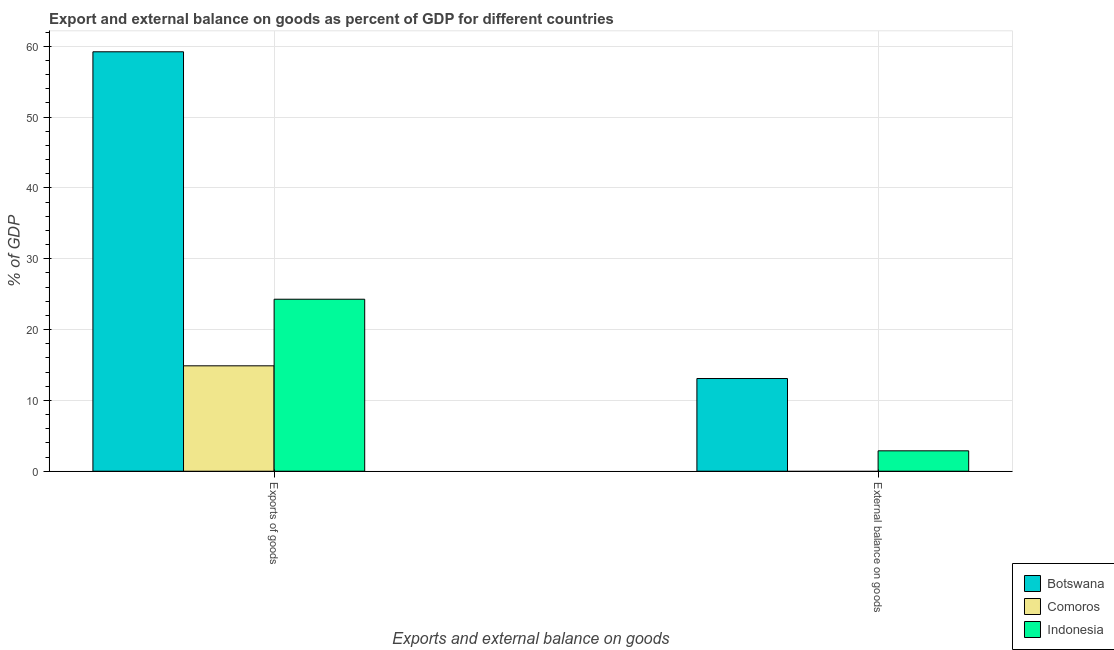How many different coloured bars are there?
Provide a succinct answer. 3. How many groups of bars are there?
Offer a terse response. 2. Are the number of bars per tick equal to the number of legend labels?
Give a very brief answer. No. How many bars are there on the 2nd tick from the right?
Give a very brief answer. 3. What is the label of the 1st group of bars from the left?
Give a very brief answer. Exports of goods. What is the export of goods as percentage of gdp in Comoros?
Your response must be concise. 14.88. Across all countries, what is the maximum export of goods as percentage of gdp?
Your response must be concise. 59.22. Across all countries, what is the minimum external balance on goods as percentage of gdp?
Give a very brief answer. 0. In which country was the export of goods as percentage of gdp maximum?
Keep it short and to the point. Botswana. What is the total export of goods as percentage of gdp in the graph?
Keep it short and to the point. 98.39. What is the difference between the export of goods as percentage of gdp in Botswana and that in Comoros?
Your answer should be very brief. 44.34. What is the difference between the external balance on goods as percentage of gdp in Botswana and the export of goods as percentage of gdp in Indonesia?
Provide a succinct answer. -11.2. What is the average export of goods as percentage of gdp per country?
Give a very brief answer. 32.8. What is the difference between the external balance on goods as percentage of gdp and export of goods as percentage of gdp in Botswana?
Ensure brevity in your answer.  -46.14. In how many countries, is the external balance on goods as percentage of gdp greater than 2 %?
Your response must be concise. 2. What is the ratio of the export of goods as percentage of gdp in Comoros to that in Indonesia?
Offer a terse response. 0.61. In how many countries, is the external balance on goods as percentage of gdp greater than the average external balance on goods as percentage of gdp taken over all countries?
Your answer should be very brief. 1. How many bars are there?
Keep it short and to the point. 5. How many countries are there in the graph?
Keep it short and to the point. 3. Does the graph contain any zero values?
Your answer should be compact. Yes. Where does the legend appear in the graph?
Make the answer very short. Bottom right. What is the title of the graph?
Ensure brevity in your answer.  Export and external balance on goods as percent of GDP for different countries. What is the label or title of the X-axis?
Ensure brevity in your answer.  Exports and external balance on goods. What is the label or title of the Y-axis?
Ensure brevity in your answer.  % of GDP. What is the % of GDP in Botswana in Exports of goods?
Provide a short and direct response. 59.22. What is the % of GDP in Comoros in Exports of goods?
Provide a short and direct response. 14.88. What is the % of GDP in Indonesia in Exports of goods?
Give a very brief answer. 24.29. What is the % of GDP of Botswana in External balance on goods?
Ensure brevity in your answer.  13.09. What is the % of GDP of Indonesia in External balance on goods?
Your response must be concise. 2.88. Across all Exports and external balance on goods, what is the maximum % of GDP of Botswana?
Provide a succinct answer. 59.22. Across all Exports and external balance on goods, what is the maximum % of GDP in Comoros?
Offer a very short reply. 14.88. Across all Exports and external balance on goods, what is the maximum % of GDP of Indonesia?
Offer a very short reply. 24.29. Across all Exports and external balance on goods, what is the minimum % of GDP of Botswana?
Offer a terse response. 13.09. Across all Exports and external balance on goods, what is the minimum % of GDP in Comoros?
Provide a short and direct response. 0. Across all Exports and external balance on goods, what is the minimum % of GDP of Indonesia?
Keep it short and to the point. 2.88. What is the total % of GDP in Botswana in the graph?
Provide a short and direct response. 72.31. What is the total % of GDP of Comoros in the graph?
Your answer should be very brief. 14.88. What is the total % of GDP of Indonesia in the graph?
Your answer should be very brief. 27.17. What is the difference between the % of GDP of Botswana in Exports of goods and that in External balance on goods?
Provide a short and direct response. 46.14. What is the difference between the % of GDP of Indonesia in Exports of goods and that in External balance on goods?
Your response must be concise. 21.41. What is the difference between the % of GDP of Botswana in Exports of goods and the % of GDP of Indonesia in External balance on goods?
Provide a succinct answer. 56.34. What is the difference between the % of GDP of Comoros in Exports of goods and the % of GDP of Indonesia in External balance on goods?
Ensure brevity in your answer.  12. What is the average % of GDP in Botswana per Exports and external balance on goods?
Keep it short and to the point. 36.16. What is the average % of GDP in Comoros per Exports and external balance on goods?
Your response must be concise. 7.44. What is the average % of GDP in Indonesia per Exports and external balance on goods?
Provide a succinct answer. 13.58. What is the difference between the % of GDP of Botswana and % of GDP of Comoros in Exports of goods?
Ensure brevity in your answer.  44.34. What is the difference between the % of GDP of Botswana and % of GDP of Indonesia in Exports of goods?
Offer a terse response. 34.94. What is the difference between the % of GDP of Comoros and % of GDP of Indonesia in Exports of goods?
Offer a very short reply. -9.4. What is the difference between the % of GDP of Botswana and % of GDP of Indonesia in External balance on goods?
Provide a succinct answer. 10.21. What is the ratio of the % of GDP of Botswana in Exports of goods to that in External balance on goods?
Give a very brief answer. 4.53. What is the ratio of the % of GDP of Indonesia in Exports of goods to that in External balance on goods?
Provide a succinct answer. 8.43. What is the difference between the highest and the second highest % of GDP of Botswana?
Provide a short and direct response. 46.14. What is the difference between the highest and the second highest % of GDP of Indonesia?
Your answer should be very brief. 21.41. What is the difference between the highest and the lowest % of GDP in Botswana?
Keep it short and to the point. 46.14. What is the difference between the highest and the lowest % of GDP in Comoros?
Provide a succinct answer. 14.88. What is the difference between the highest and the lowest % of GDP of Indonesia?
Provide a short and direct response. 21.41. 